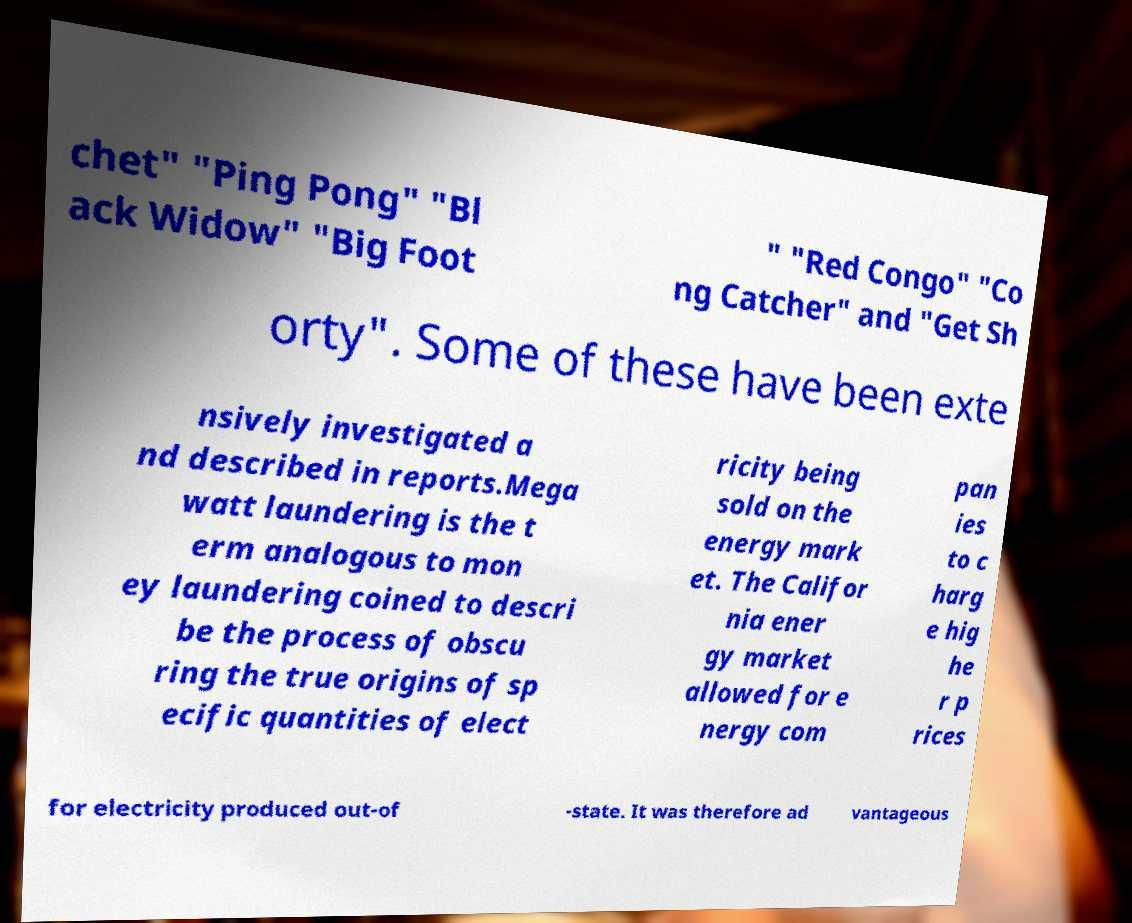Can you read and provide the text displayed in the image?This photo seems to have some interesting text. Can you extract and type it out for me? chet" "Ping Pong" "Bl ack Widow" "Big Foot " "Red Congo" "Co ng Catcher" and "Get Sh orty". Some of these have been exte nsively investigated a nd described in reports.Mega watt laundering is the t erm analogous to mon ey laundering coined to descri be the process of obscu ring the true origins of sp ecific quantities of elect ricity being sold on the energy mark et. The Califor nia ener gy market allowed for e nergy com pan ies to c harg e hig he r p rices for electricity produced out-of -state. It was therefore ad vantageous 